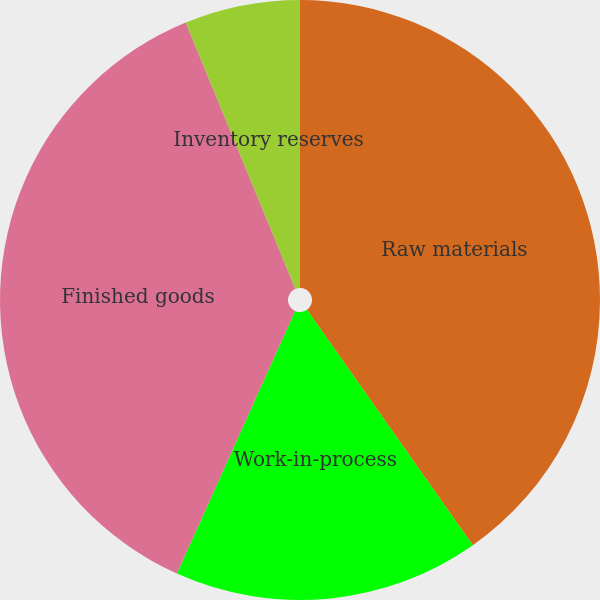<chart> <loc_0><loc_0><loc_500><loc_500><pie_chart><fcel>Raw materials<fcel>Work-in-process<fcel>Finished goods<fcel>Inventory reserves<nl><fcel>40.23%<fcel>16.5%<fcel>37.05%<fcel>6.22%<nl></chart> 